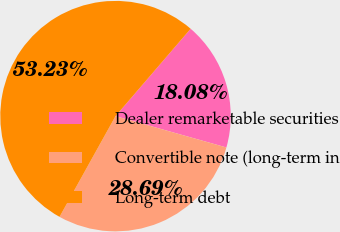Convert chart. <chart><loc_0><loc_0><loc_500><loc_500><pie_chart><fcel>Dealer remarketable securities<fcel>Convertible note (long-term in<fcel>Long-term debt<nl><fcel>18.08%<fcel>28.69%<fcel>53.23%<nl></chart> 